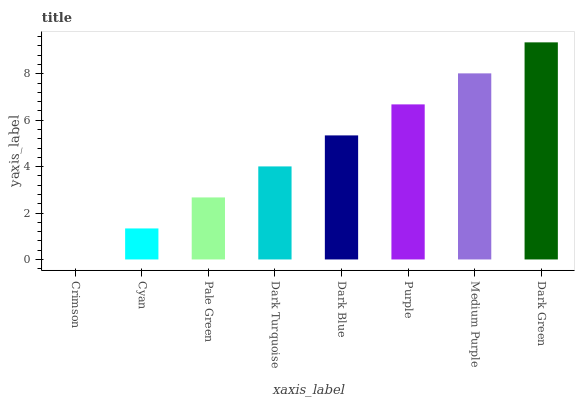Is Crimson the minimum?
Answer yes or no. Yes. Is Dark Green the maximum?
Answer yes or no. Yes. Is Cyan the minimum?
Answer yes or no. No. Is Cyan the maximum?
Answer yes or no. No. Is Cyan greater than Crimson?
Answer yes or no. Yes. Is Crimson less than Cyan?
Answer yes or no. Yes. Is Crimson greater than Cyan?
Answer yes or no. No. Is Cyan less than Crimson?
Answer yes or no. No. Is Dark Blue the high median?
Answer yes or no. Yes. Is Dark Turquoise the low median?
Answer yes or no. Yes. Is Cyan the high median?
Answer yes or no. No. Is Dark Blue the low median?
Answer yes or no. No. 